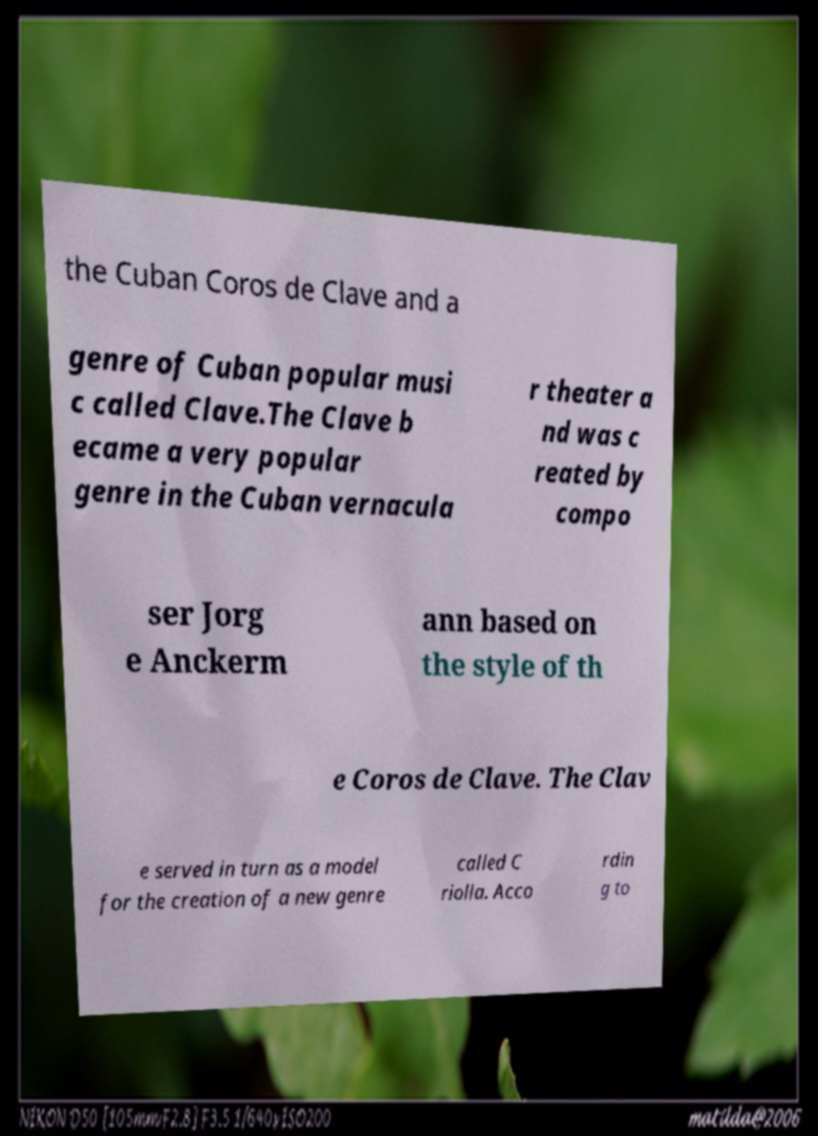Could you extract and type out the text from this image? the Cuban Coros de Clave and a genre of Cuban popular musi c called Clave.The Clave b ecame a very popular genre in the Cuban vernacula r theater a nd was c reated by compo ser Jorg e Anckerm ann based on the style of th e Coros de Clave. The Clav e served in turn as a model for the creation of a new genre called C riolla. Acco rdin g to 